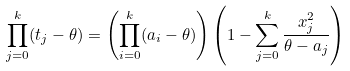<formula> <loc_0><loc_0><loc_500><loc_500>\prod _ { j = 0 } ^ { k } ( t _ { j } - \theta ) = \left ( \prod _ { i = 0 } ^ { k } ( a _ { i } - \theta ) \right ) \left ( 1 - \sum _ { j = 0 } ^ { k } \frac { x _ { j } ^ { 2 } } { \theta - a _ { j } } \right )</formula> 